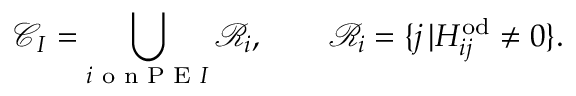Convert formula to latex. <formula><loc_0><loc_0><loc_500><loc_500>\mathcal { C } _ { I } = \bigcup _ { i o n P E I } \mathcal { R } _ { i } , \quad \mathcal { R } _ { i } = \{ j \, | H _ { i j } ^ { o d } \neq 0 \} .</formula> 